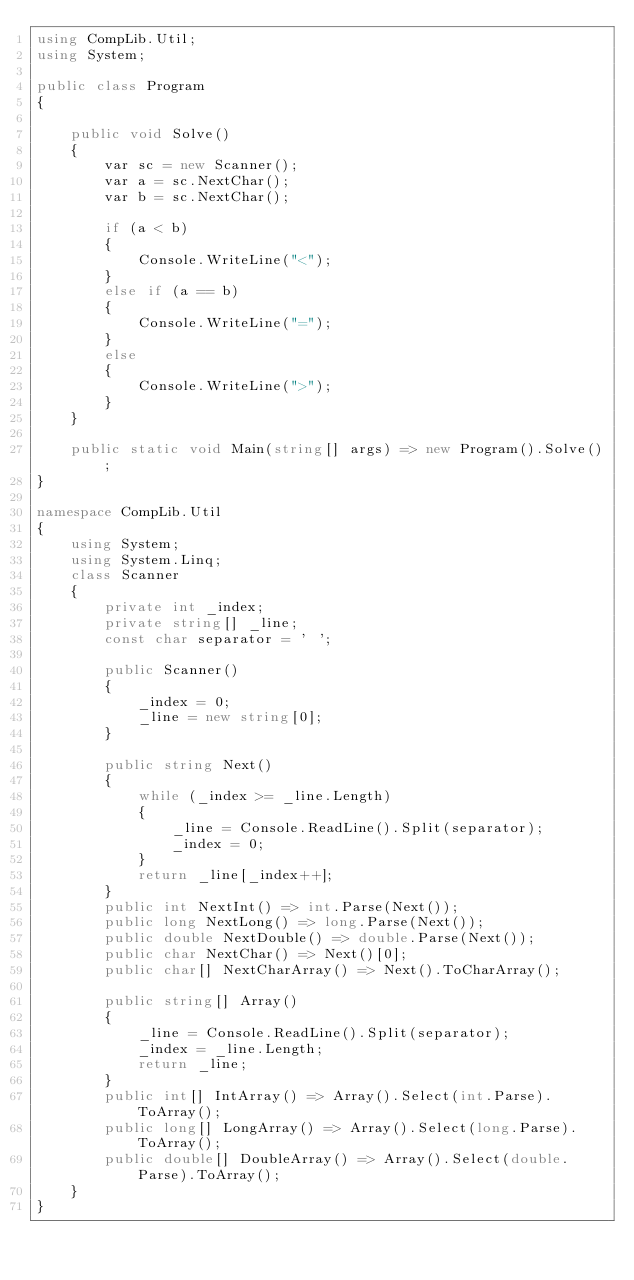<code> <loc_0><loc_0><loc_500><loc_500><_C#_>using CompLib.Util;
using System;

public class Program
{

    public void Solve()
    {
        var sc = new Scanner();
        var a = sc.NextChar();
        var b = sc.NextChar();

        if (a < b)
        {
            Console.WriteLine("<");
        }
        else if (a == b)
        {
            Console.WriteLine("=");
        }
        else
        {
            Console.WriteLine(">");
        }
    }

    public static void Main(string[] args) => new Program().Solve();
}

namespace CompLib.Util
{
    using System;
    using System.Linq;
    class Scanner
    {
        private int _index;
        private string[] _line;
        const char separator = ' ';

        public Scanner()
        {
            _index = 0;
            _line = new string[0];
        }

        public string Next()
        {
            while (_index >= _line.Length)
            {
                _line = Console.ReadLine().Split(separator);
                _index = 0;
            }
            return _line[_index++];
        }
        public int NextInt() => int.Parse(Next());
        public long NextLong() => long.Parse(Next());
        public double NextDouble() => double.Parse(Next());
        public char NextChar() => Next()[0];
        public char[] NextCharArray() => Next().ToCharArray();

        public string[] Array()
        {
            _line = Console.ReadLine().Split(separator);
            _index = _line.Length;
            return _line;
        }
        public int[] IntArray() => Array().Select(int.Parse).ToArray();
        public long[] LongArray() => Array().Select(long.Parse).ToArray();
        public double[] DoubleArray() => Array().Select(double.Parse).ToArray();
    }
}</code> 